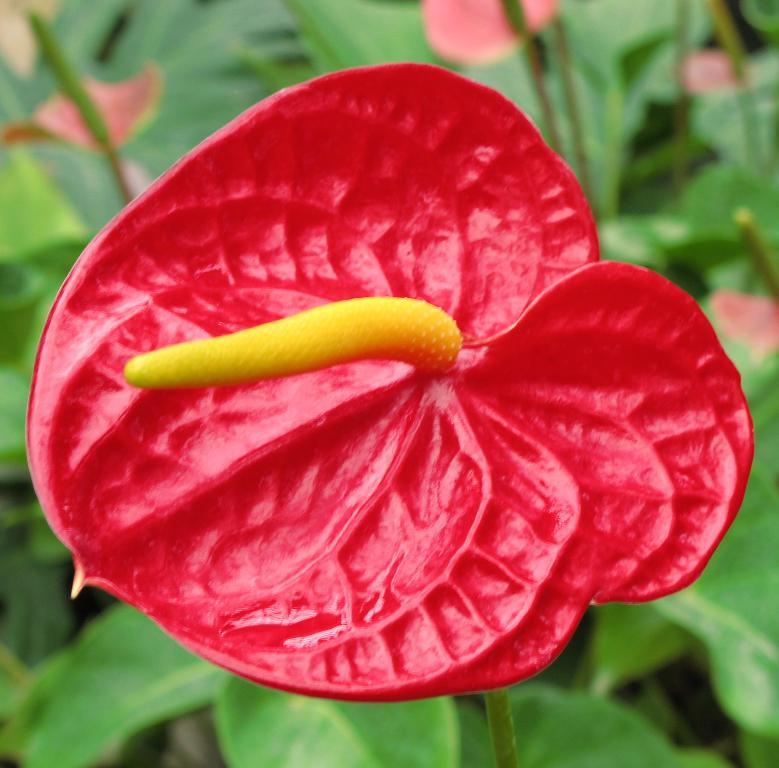What is the main subject of the image? The main subject of the image is a flower. Can you describe the flower's structure? The flower has a stem and leaves around it. What type of pencil is being used by the giant in the competition in the image? There is no giant, competition, or pencil present in the image; it features a flower with a stem and leaves. 